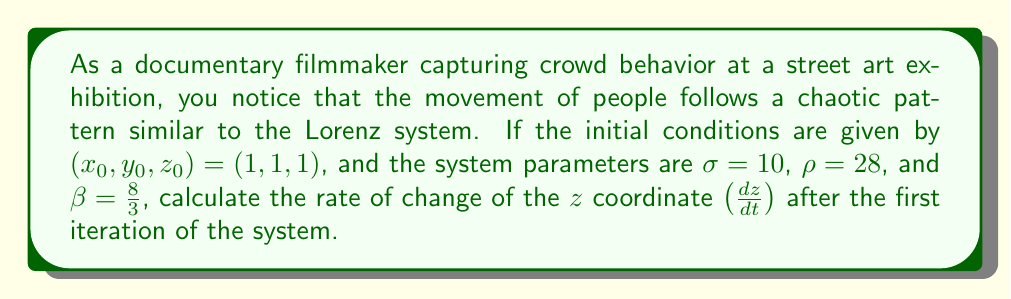Show me your answer to this math problem. To solve this problem, we'll use the Lorenz system equations and follow these steps:

1. Recall the Lorenz system equations:
   $$\frac{dx}{dt} = \sigma(y - x)$$
   $$\frac{dy}{dt} = x(\rho - z) - y$$
   $$\frac{dz}{dt} = xy - \beta z$$

2. Given initial conditions: $(x_0, y_0, z_0) = (1, 1, 1)$

3. Calculate $\frac{dx}{dt}$ for the first iteration:
   $$\frac{dx}{dt} = \sigma(y_0 - x_0) = 10(1 - 1) = 0$$

4. Calculate $\frac{dy}{dt}$ for the first iteration:
   $$\frac{dy}{dt} = x_0(\rho - z_0) - y_0 = 1(28 - 1) - 1 = 26$$

5. Calculate $\frac{dz}{dt}$ for the first iteration:
   $$\frac{dz}{dt} = x_0y_0 - \beta z_0 = 1 \cdot 1 - \frac{8}{3} \cdot 1 = 1 - \frac{8}{3} = -\frac{5}{3}$$

The rate of change of the $z$ coordinate after the first iteration is $-\frac{5}{3}$.
Answer: $-\frac{5}{3}$ 